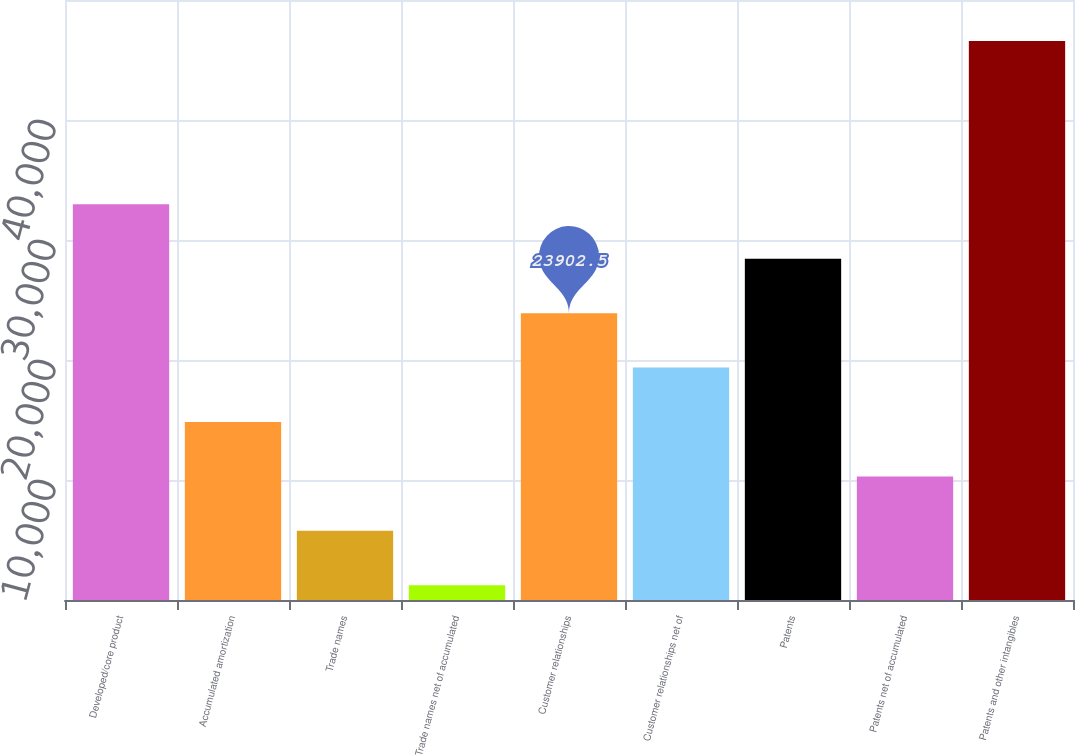<chart> <loc_0><loc_0><loc_500><loc_500><bar_chart><fcel>Developed/core product<fcel>Accumulated amortization<fcel>Trade names<fcel>Trade names net of accumulated<fcel>Customer relationships<fcel>Customer relationships net of<fcel>Patents<fcel>Patents net of accumulated<fcel>Patents and other intangibles<nl><fcel>32971.5<fcel>14833.5<fcel>5764.5<fcel>1230<fcel>23902.5<fcel>19368<fcel>28437<fcel>10299<fcel>46575<nl></chart> 